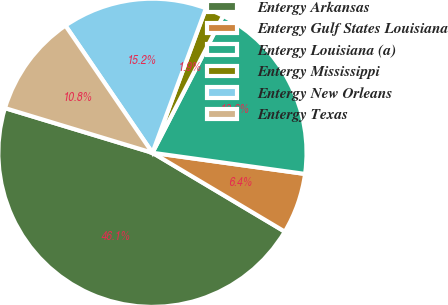Convert chart to OTSL. <chart><loc_0><loc_0><loc_500><loc_500><pie_chart><fcel>Entergy Arkansas<fcel>Entergy Gulf States Louisiana<fcel>Entergy Louisiana (a)<fcel>Entergy Mississippi<fcel>Entergy New Orleans<fcel>Entergy Texas<nl><fcel>46.13%<fcel>6.36%<fcel>19.61%<fcel>1.94%<fcel>15.19%<fcel>10.77%<nl></chart> 